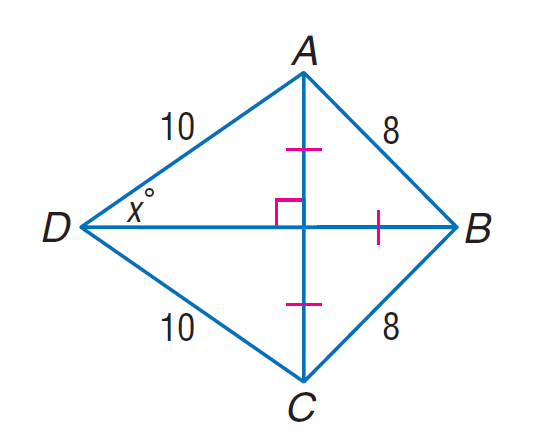Answer the mathemtical geometry problem and directly provide the correct option letter.
Question: Find \sin x.
Choices: A: \frac { \sqrt { 2 } } { 10 } B: \frac { \sqrt { 2 } } { 5 } C: \frac { \sqrt { 5 } } { 5 } D: \frac { 2 \sqrt { 2 } } { 5 } D 